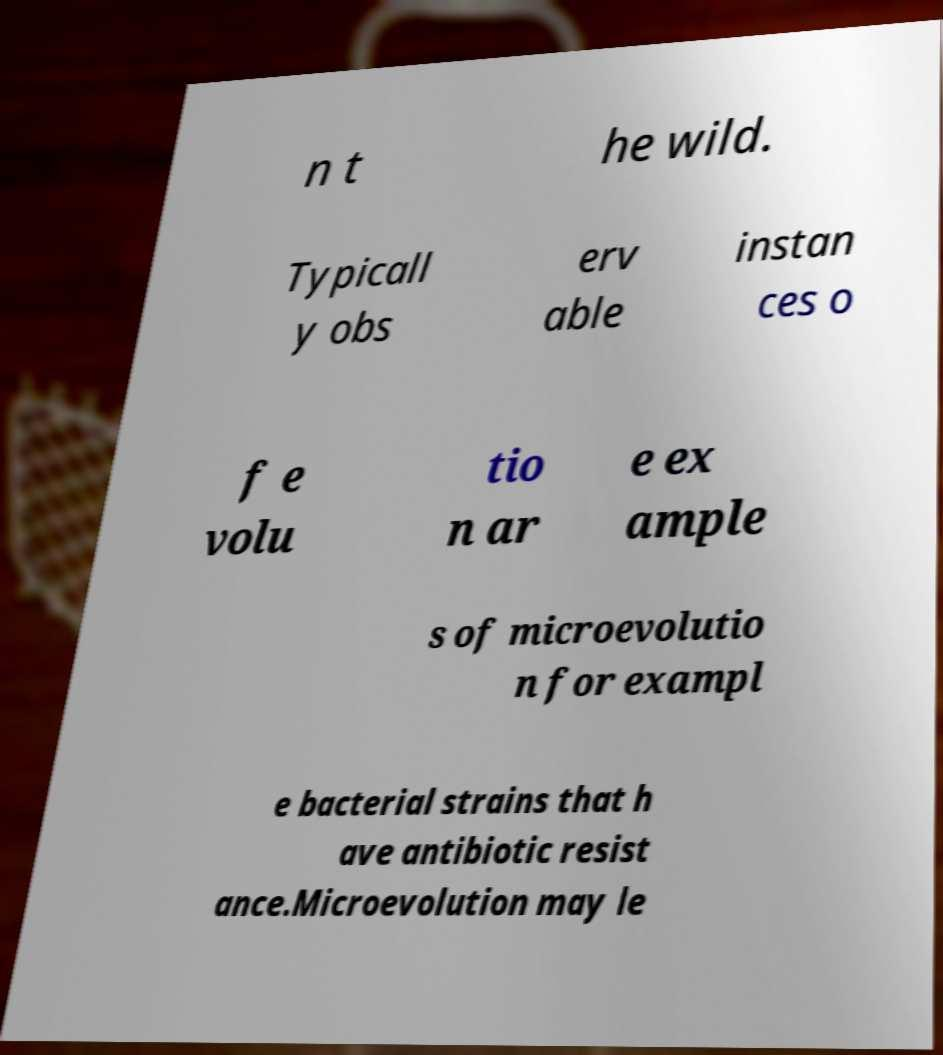Could you extract and type out the text from this image? n t he wild. Typicall y obs erv able instan ces o f e volu tio n ar e ex ample s of microevolutio n for exampl e bacterial strains that h ave antibiotic resist ance.Microevolution may le 